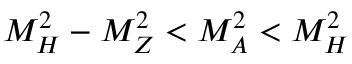Convert formula to latex. <formula><loc_0><loc_0><loc_500><loc_500>M _ { H } ^ { 2 } - M _ { Z } ^ { 2 } < M _ { A } ^ { 2 } < M _ { H } ^ { 2 }</formula> 